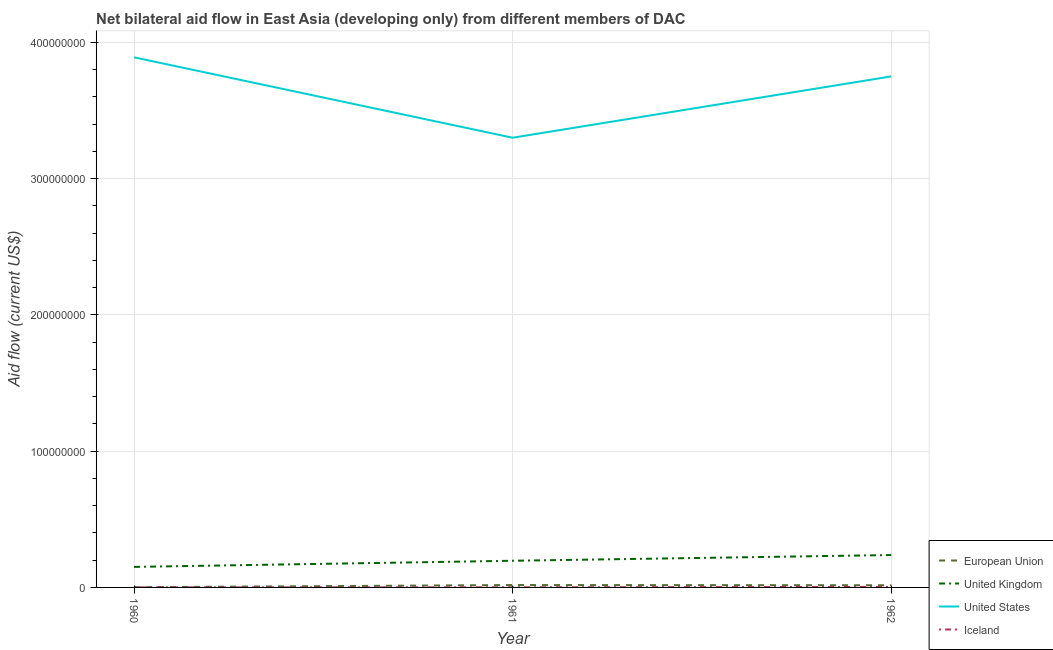Does the line corresponding to amount of aid given by iceland intersect with the line corresponding to amount of aid given by us?
Your answer should be compact. No. What is the amount of aid given by eu in 1960?
Your answer should be compact. 1.60e+05. Across all years, what is the maximum amount of aid given by us?
Your answer should be compact. 3.89e+08. Across all years, what is the minimum amount of aid given by us?
Offer a terse response. 3.30e+08. What is the total amount of aid given by us in the graph?
Your answer should be compact. 1.09e+09. What is the difference between the amount of aid given by eu in 1960 and that in 1961?
Provide a short and direct response. -1.58e+06. What is the difference between the amount of aid given by uk in 1962 and the amount of aid given by eu in 1960?
Your answer should be compact. 2.36e+07. What is the average amount of aid given by eu per year?
Keep it short and to the point. 1.16e+06. In the year 1961, what is the difference between the amount of aid given by uk and amount of aid given by iceland?
Your response must be concise. 1.95e+07. In how many years, is the amount of aid given by us greater than 40000000 US$?
Give a very brief answer. 3. What is the ratio of the amount of aid given by iceland in 1961 to that in 1962?
Offer a very short reply. 0.2. What is the difference between the highest and the second highest amount of aid given by iceland?
Make the answer very short. 3.20e+05. What is the difference between the highest and the lowest amount of aid given by iceland?
Make the answer very short. 3.40e+05. Is the sum of the amount of aid given by us in 1961 and 1962 greater than the maximum amount of aid given by iceland across all years?
Offer a terse response. Yes. What is the difference between two consecutive major ticks on the Y-axis?
Offer a very short reply. 1.00e+08. Does the graph contain any zero values?
Provide a short and direct response. No. Does the graph contain grids?
Your answer should be compact. Yes. Where does the legend appear in the graph?
Your answer should be very brief. Bottom right. How are the legend labels stacked?
Offer a very short reply. Vertical. What is the title of the graph?
Your answer should be compact. Net bilateral aid flow in East Asia (developing only) from different members of DAC. Does "Belgium" appear as one of the legend labels in the graph?
Your answer should be compact. No. What is the Aid flow (current US$) in United Kingdom in 1960?
Give a very brief answer. 1.51e+07. What is the Aid flow (current US$) in United States in 1960?
Make the answer very short. 3.89e+08. What is the Aid flow (current US$) in Iceland in 1960?
Provide a short and direct response. 6.00e+04. What is the Aid flow (current US$) of European Union in 1961?
Give a very brief answer. 1.74e+06. What is the Aid flow (current US$) of United Kingdom in 1961?
Your answer should be compact. 1.96e+07. What is the Aid flow (current US$) of United States in 1961?
Your response must be concise. 3.30e+08. What is the Aid flow (current US$) in European Union in 1962?
Provide a succinct answer. 1.58e+06. What is the Aid flow (current US$) in United Kingdom in 1962?
Offer a very short reply. 2.38e+07. What is the Aid flow (current US$) of United States in 1962?
Offer a very short reply. 3.75e+08. Across all years, what is the maximum Aid flow (current US$) in European Union?
Your answer should be very brief. 1.74e+06. Across all years, what is the maximum Aid flow (current US$) of United Kingdom?
Make the answer very short. 2.38e+07. Across all years, what is the maximum Aid flow (current US$) of United States?
Keep it short and to the point. 3.89e+08. Across all years, what is the maximum Aid flow (current US$) in Iceland?
Your response must be concise. 4.00e+05. Across all years, what is the minimum Aid flow (current US$) of United Kingdom?
Give a very brief answer. 1.51e+07. Across all years, what is the minimum Aid flow (current US$) in United States?
Ensure brevity in your answer.  3.30e+08. What is the total Aid flow (current US$) of European Union in the graph?
Provide a succinct answer. 3.48e+06. What is the total Aid flow (current US$) of United Kingdom in the graph?
Keep it short and to the point. 5.84e+07. What is the total Aid flow (current US$) of United States in the graph?
Provide a succinct answer. 1.09e+09. What is the total Aid flow (current US$) of Iceland in the graph?
Your response must be concise. 5.40e+05. What is the difference between the Aid flow (current US$) in European Union in 1960 and that in 1961?
Your answer should be very brief. -1.58e+06. What is the difference between the Aid flow (current US$) of United Kingdom in 1960 and that in 1961?
Your answer should be compact. -4.51e+06. What is the difference between the Aid flow (current US$) of United States in 1960 and that in 1961?
Your response must be concise. 5.90e+07. What is the difference between the Aid flow (current US$) in European Union in 1960 and that in 1962?
Offer a terse response. -1.42e+06. What is the difference between the Aid flow (current US$) of United Kingdom in 1960 and that in 1962?
Provide a short and direct response. -8.70e+06. What is the difference between the Aid flow (current US$) in United States in 1960 and that in 1962?
Your answer should be compact. 1.40e+07. What is the difference between the Aid flow (current US$) in United Kingdom in 1961 and that in 1962?
Your answer should be very brief. -4.19e+06. What is the difference between the Aid flow (current US$) in United States in 1961 and that in 1962?
Keep it short and to the point. -4.50e+07. What is the difference between the Aid flow (current US$) in Iceland in 1961 and that in 1962?
Make the answer very short. -3.20e+05. What is the difference between the Aid flow (current US$) in European Union in 1960 and the Aid flow (current US$) in United Kingdom in 1961?
Your answer should be very brief. -1.94e+07. What is the difference between the Aid flow (current US$) in European Union in 1960 and the Aid flow (current US$) in United States in 1961?
Provide a short and direct response. -3.30e+08. What is the difference between the Aid flow (current US$) in European Union in 1960 and the Aid flow (current US$) in Iceland in 1961?
Offer a very short reply. 8.00e+04. What is the difference between the Aid flow (current US$) in United Kingdom in 1960 and the Aid flow (current US$) in United States in 1961?
Provide a succinct answer. -3.15e+08. What is the difference between the Aid flow (current US$) of United Kingdom in 1960 and the Aid flow (current US$) of Iceland in 1961?
Offer a terse response. 1.50e+07. What is the difference between the Aid flow (current US$) in United States in 1960 and the Aid flow (current US$) in Iceland in 1961?
Make the answer very short. 3.89e+08. What is the difference between the Aid flow (current US$) of European Union in 1960 and the Aid flow (current US$) of United Kingdom in 1962?
Your response must be concise. -2.36e+07. What is the difference between the Aid flow (current US$) of European Union in 1960 and the Aid flow (current US$) of United States in 1962?
Offer a terse response. -3.75e+08. What is the difference between the Aid flow (current US$) in European Union in 1960 and the Aid flow (current US$) in Iceland in 1962?
Give a very brief answer. -2.40e+05. What is the difference between the Aid flow (current US$) of United Kingdom in 1960 and the Aid flow (current US$) of United States in 1962?
Offer a very short reply. -3.60e+08. What is the difference between the Aid flow (current US$) of United Kingdom in 1960 and the Aid flow (current US$) of Iceland in 1962?
Your answer should be very brief. 1.47e+07. What is the difference between the Aid flow (current US$) in United States in 1960 and the Aid flow (current US$) in Iceland in 1962?
Give a very brief answer. 3.89e+08. What is the difference between the Aid flow (current US$) of European Union in 1961 and the Aid flow (current US$) of United Kingdom in 1962?
Provide a short and direct response. -2.20e+07. What is the difference between the Aid flow (current US$) of European Union in 1961 and the Aid flow (current US$) of United States in 1962?
Keep it short and to the point. -3.73e+08. What is the difference between the Aid flow (current US$) in European Union in 1961 and the Aid flow (current US$) in Iceland in 1962?
Offer a terse response. 1.34e+06. What is the difference between the Aid flow (current US$) of United Kingdom in 1961 and the Aid flow (current US$) of United States in 1962?
Keep it short and to the point. -3.55e+08. What is the difference between the Aid flow (current US$) of United Kingdom in 1961 and the Aid flow (current US$) of Iceland in 1962?
Your answer should be very brief. 1.92e+07. What is the difference between the Aid flow (current US$) in United States in 1961 and the Aid flow (current US$) in Iceland in 1962?
Provide a succinct answer. 3.30e+08. What is the average Aid flow (current US$) in European Union per year?
Your response must be concise. 1.16e+06. What is the average Aid flow (current US$) of United Kingdom per year?
Provide a short and direct response. 1.95e+07. What is the average Aid flow (current US$) of United States per year?
Make the answer very short. 3.65e+08. In the year 1960, what is the difference between the Aid flow (current US$) in European Union and Aid flow (current US$) in United Kingdom?
Your response must be concise. -1.49e+07. In the year 1960, what is the difference between the Aid flow (current US$) of European Union and Aid flow (current US$) of United States?
Give a very brief answer. -3.89e+08. In the year 1960, what is the difference between the Aid flow (current US$) of United Kingdom and Aid flow (current US$) of United States?
Provide a short and direct response. -3.74e+08. In the year 1960, what is the difference between the Aid flow (current US$) of United Kingdom and Aid flow (current US$) of Iceland?
Your answer should be very brief. 1.50e+07. In the year 1960, what is the difference between the Aid flow (current US$) in United States and Aid flow (current US$) in Iceland?
Offer a terse response. 3.89e+08. In the year 1961, what is the difference between the Aid flow (current US$) of European Union and Aid flow (current US$) of United Kingdom?
Offer a very short reply. -1.78e+07. In the year 1961, what is the difference between the Aid flow (current US$) of European Union and Aid flow (current US$) of United States?
Ensure brevity in your answer.  -3.28e+08. In the year 1961, what is the difference between the Aid flow (current US$) in European Union and Aid flow (current US$) in Iceland?
Your answer should be compact. 1.66e+06. In the year 1961, what is the difference between the Aid flow (current US$) of United Kingdom and Aid flow (current US$) of United States?
Provide a short and direct response. -3.10e+08. In the year 1961, what is the difference between the Aid flow (current US$) of United Kingdom and Aid flow (current US$) of Iceland?
Provide a succinct answer. 1.95e+07. In the year 1961, what is the difference between the Aid flow (current US$) in United States and Aid flow (current US$) in Iceland?
Keep it short and to the point. 3.30e+08. In the year 1962, what is the difference between the Aid flow (current US$) in European Union and Aid flow (current US$) in United Kingdom?
Your response must be concise. -2.22e+07. In the year 1962, what is the difference between the Aid flow (current US$) in European Union and Aid flow (current US$) in United States?
Ensure brevity in your answer.  -3.73e+08. In the year 1962, what is the difference between the Aid flow (current US$) in European Union and Aid flow (current US$) in Iceland?
Give a very brief answer. 1.18e+06. In the year 1962, what is the difference between the Aid flow (current US$) in United Kingdom and Aid flow (current US$) in United States?
Provide a succinct answer. -3.51e+08. In the year 1962, what is the difference between the Aid flow (current US$) in United Kingdom and Aid flow (current US$) in Iceland?
Give a very brief answer. 2.34e+07. In the year 1962, what is the difference between the Aid flow (current US$) in United States and Aid flow (current US$) in Iceland?
Provide a succinct answer. 3.75e+08. What is the ratio of the Aid flow (current US$) in European Union in 1960 to that in 1961?
Ensure brevity in your answer.  0.09. What is the ratio of the Aid flow (current US$) in United Kingdom in 1960 to that in 1961?
Provide a short and direct response. 0.77. What is the ratio of the Aid flow (current US$) of United States in 1960 to that in 1961?
Keep it short and to the point. 1.18. What is the ratio of the Aid flow (current US$) of European Union in 1960 to that in 1962?
Ensure brevity in your answer.  0.1. What is the ratio of the Aid flow (current US$) in United Kingdom in 1960 to that in 1962?
Your answer should be very brief. 0.63. What is the ratio of the Aid flow (current US$) in United States in 1960 to that in 1962?
Ensure brevity in your answer.  1.04. What is the ratio of the Aid flow (current US$) in European Union in 1961 to that in 1962?
Offer a very short reply. 1.1. What is the ratio of the Aid flow (current US$) in United Kingdom in 1961 to that in 1962?
Provide a short and direct response. 0.82. What is the ratio of the Aid flow (current US$) of United States in 1961 to that in 1962?
Provide a short and direct response. 0.88. What is the difference between the highest and the second highest Aid flow (current US$) in United Kingdom?
Make the answer very short. 4.19e+06. What is the difference between the highest and the second highest Aid flow (current US$) in United States?
Ensure brevity in your answer.  1.40e+07. What is the difference between the highest and the second highest Aid flow (current US$) in Iceland?
Make the answer very short. 3.20e+05. What is the difference between the highest and the lowest Aid flow (current US$) in European Union?
Keep it short and to the point. 1.58e+06. What is the difference between the highest and the lowest Aid flow (current US$) of United Kingdom?
Your response must be concise. 8.70e+06. What is the difference between the highest and the lowest Aid flow (current US$) of United States?
Your answer should be very brief. 5.90e+07. 